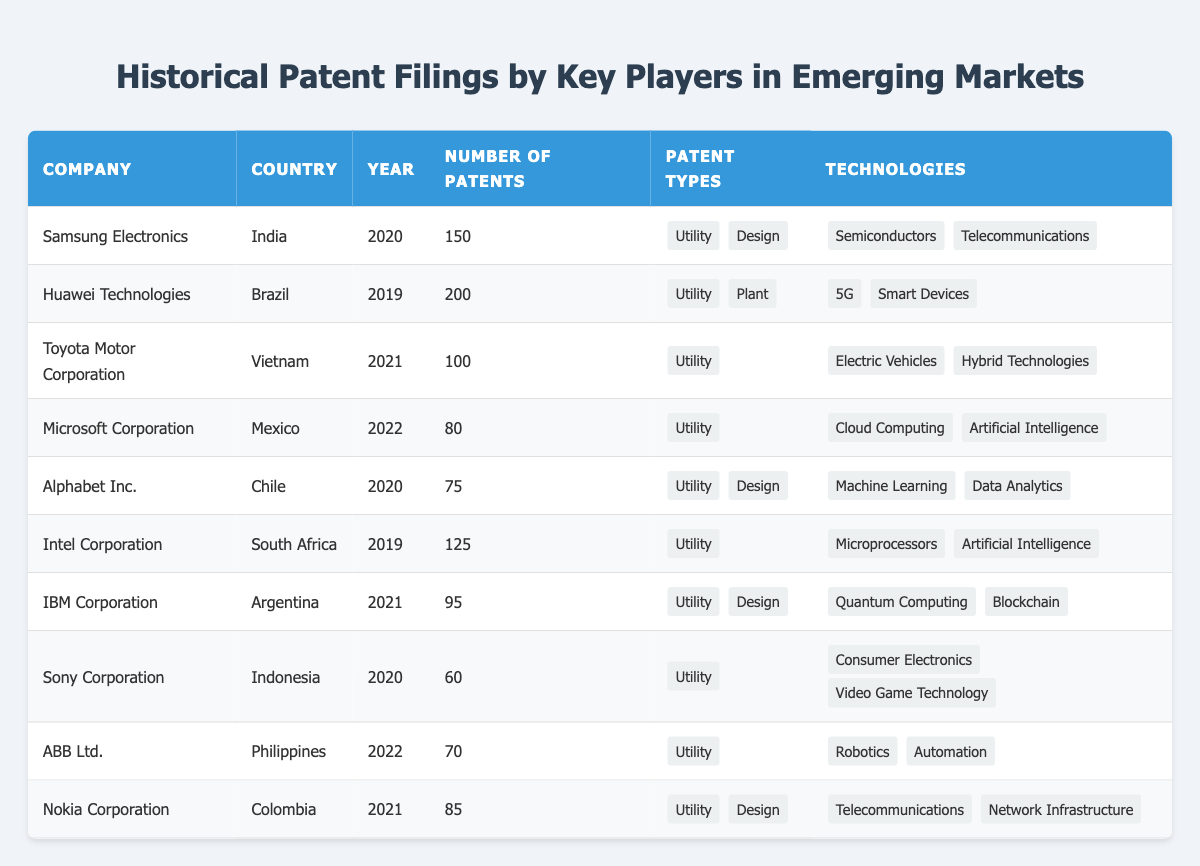What company filed the most patents in Brazil? According to the table, Huawei Technologies filed 200 patents in Brazil in the year 2019, which is the highest number for that country.
Answer: Huawei Technologies How many patents did Microsoft Corporation file in Mexico? The table shows that Microsoft Corporation filed 80 patents in Mexico in 2022.
Answer: 80 Which company focused on electric vehicles as a technology in Vietnam? The table indicates that Toyota Motor Corporation, which filed 100 patents in Vietnam in 2021, focused on electric vehicles as one of its technologies.
Answer: Toyota Motor Corporation What is the total number of patents filed by Samsung Electronics and Sony Corporation combined? Samsung Electronics filed 150 patents in India and Sony Corporation filed 60 patents in Indonesia. Adding those together gives 150 + 60 = 210.
Answer: 210 In which year did IBM Corporation file patents in Argentina? The table states that IBM Corporation filed patents in 2021 in Argentina.
Answer: 2021 Did any company file patents related to both telecommunications and artificial intelligence? Yes, Intel Corporation focused on artificial intelligence while Samsung Electronics concentrated on telecommunications, so two companies targeted both fields.
Answer: Yes Which country had the least number of patents filed by a single company in this data? The table shows that Sony Corporation filed the least number of patents with a total of 60 in Indonesia.
Answer: Indonesia What percentage of patent filings did Toyota Motor Corporation contribute compared to Huawei Technologies? Toyota filed 100 patents while Huawei filed 200. To find the percentage: (100/200) * 100 = 50%.
Answer: 50% Which company had the highest number of utility patents? By examining the table for utility patents, Huawei Technologies (200) holds the highest count, followed by Samsung Electronics (150) and Intel Corporation (125).
Answer: Huawei Technologies Was ABB Ltd. focused solely on utility patents in the Philippines? Yes, the table specified that ABB Ltd. filed a total of 70 patents, all categorized as utility patents in the Philippines.
Answer: Yes What were the primary technologies of companies that filed more than 100 patents? Looking at the data, both Huawei Technologies (5G, Smart Devices) and Samsung Electronics (Semiconductors, Telecommunications) filed more than 100 patents, showing they worked on innovative technologies.
Answer: 5G, Smart Devices; Semiconductors, Telecommunications 